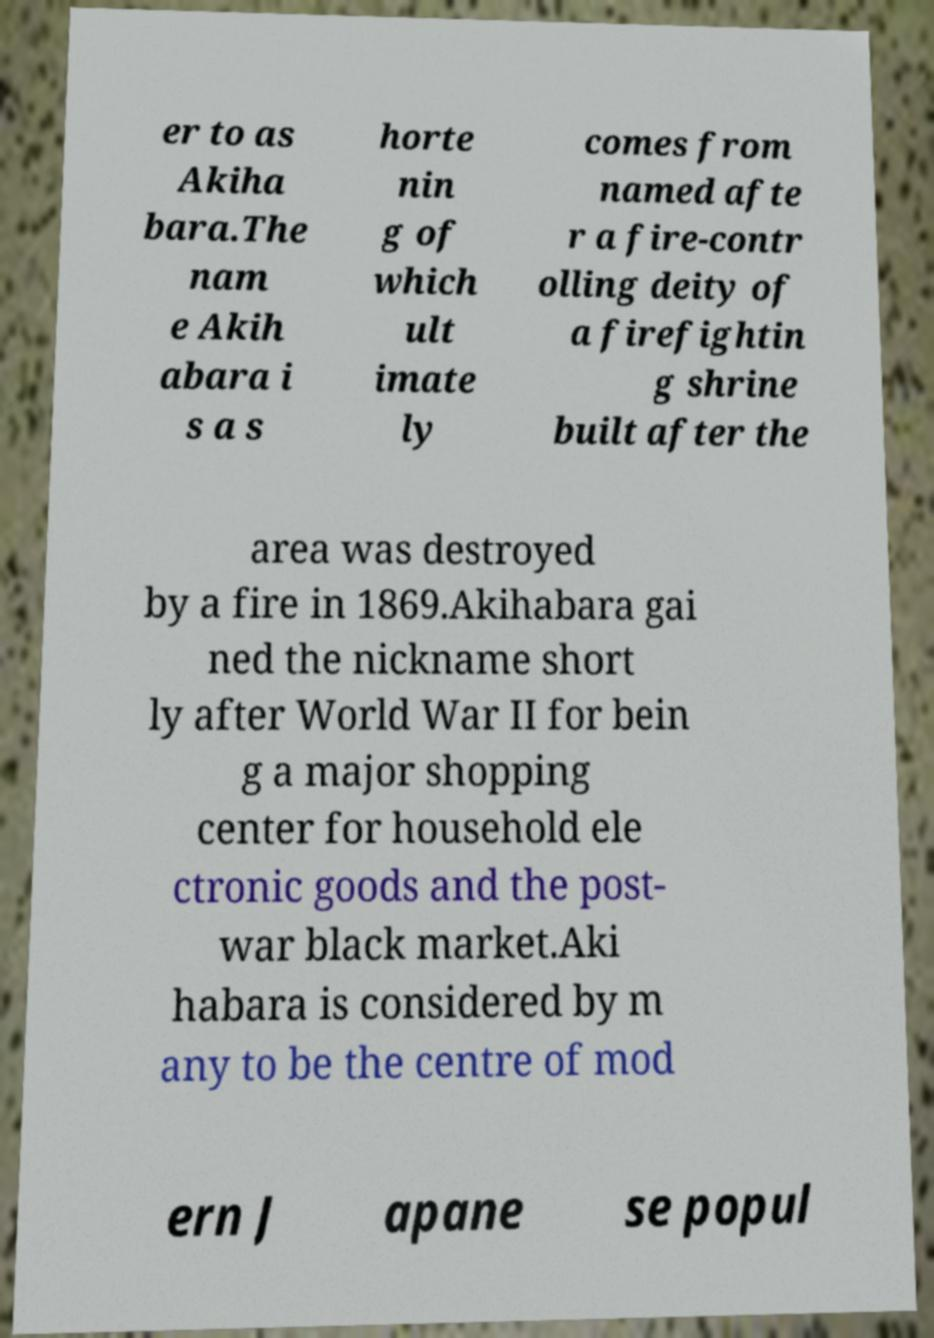I need the written content from this picture converted into text. Can you do that? er to as Akiha bara.The nam e Akih abara i s a s horte nin g of which ult imate ly comes from named afte r a fire-contr olling deity of a firefightin g shrine built after the area was destroyed by a fire in 1869.Akihabara gai ned the nickname short ly after World War II for bein g a major shopping center for household ele ctronic goods and the post- war black market.Aki habara is considered by m any to be the centre of mod ern J apane se popul 